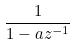<formula> <loc_0><loc_0><loc_500><loc_500>\frac { 1 } { 1 - a z ^ { - 1 } }</formula> 